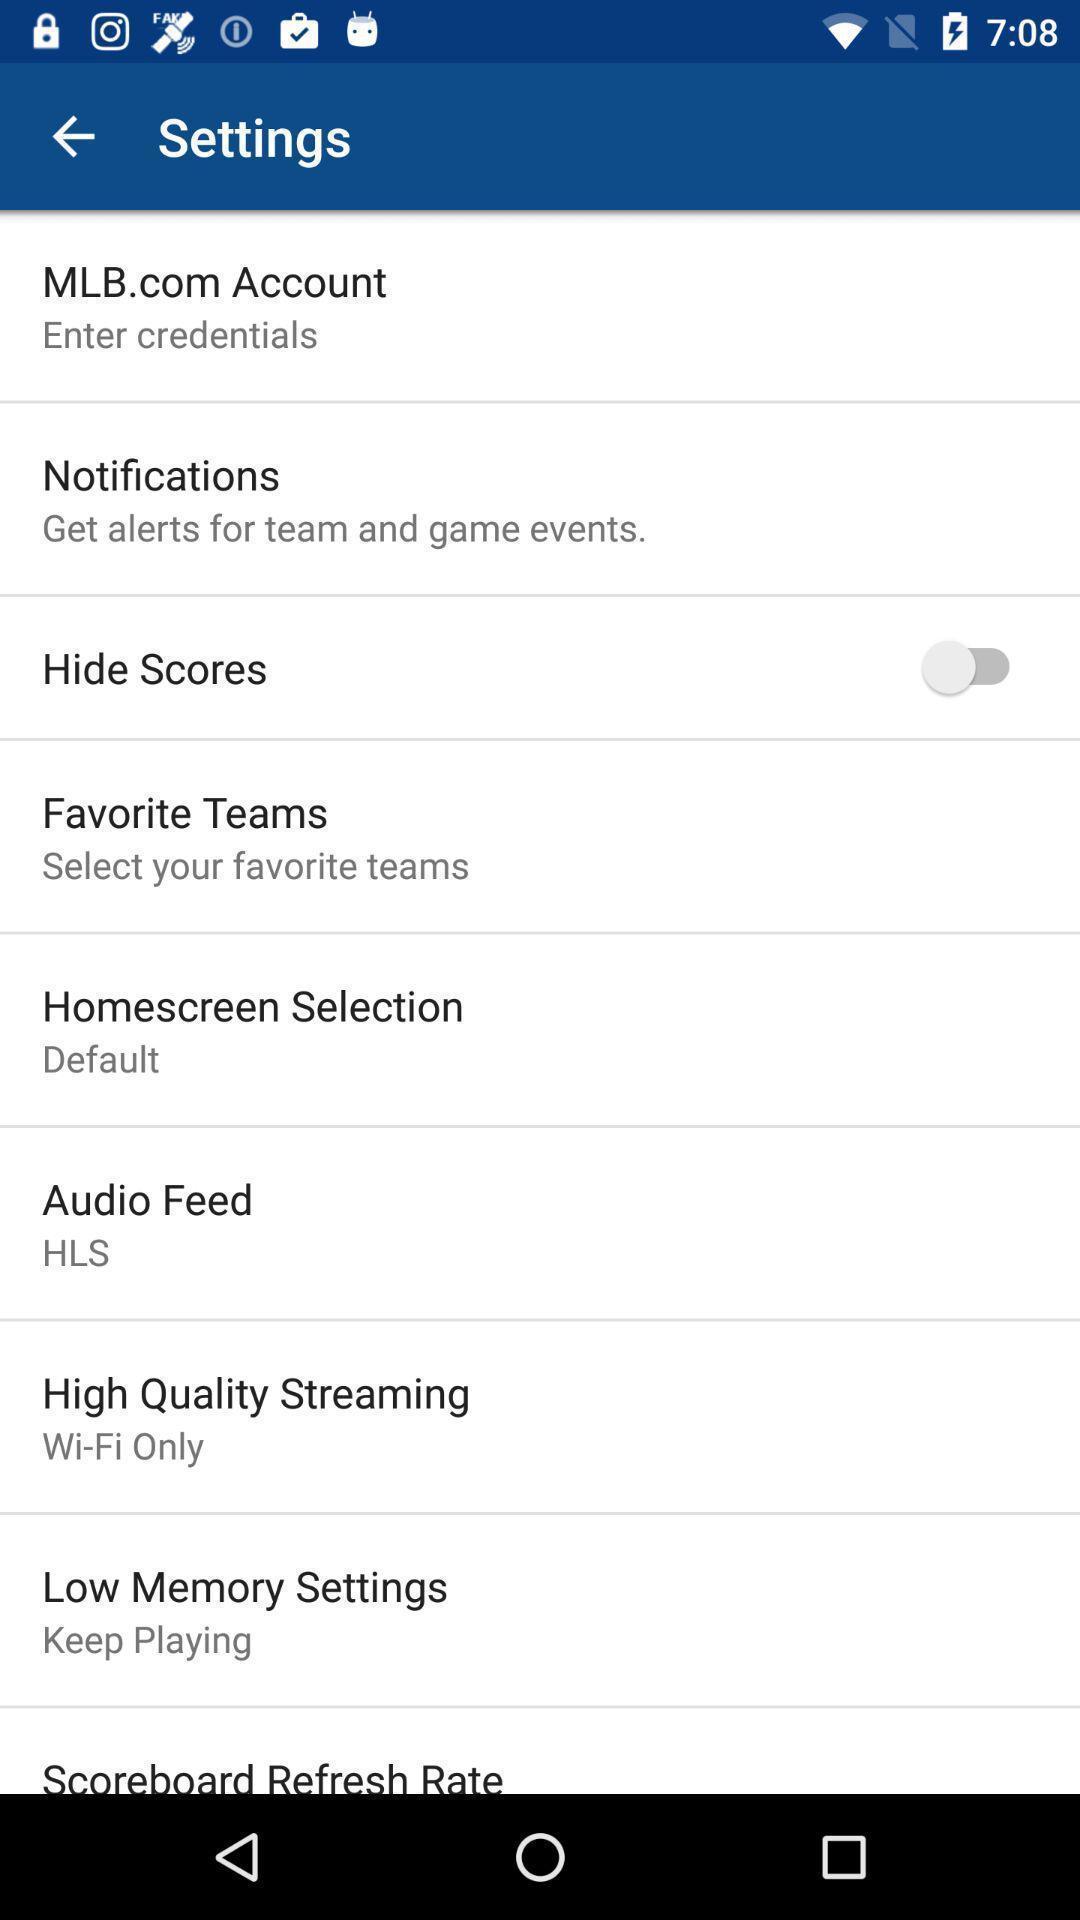Summarize the information in this screenshot. Page showing a variety of settings. 